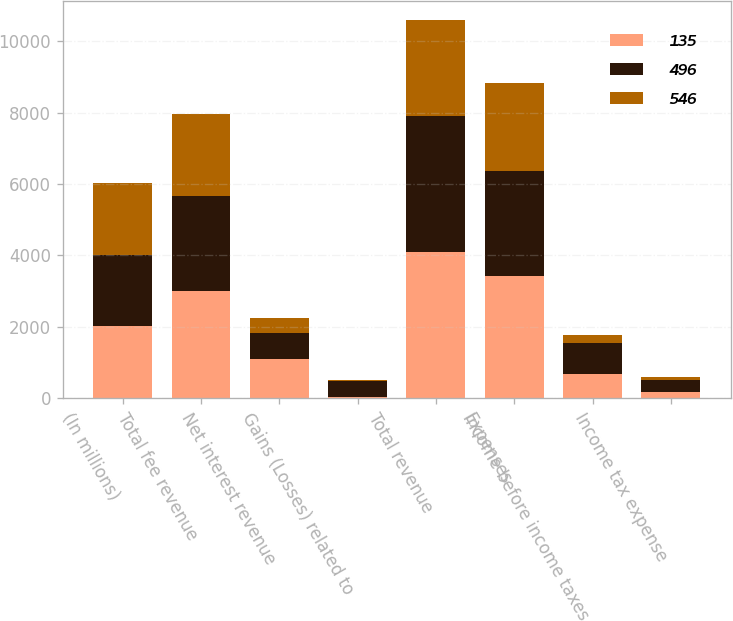Convert chart. <chart><loc_0><loc_0><loc_500><loc_500><stacked_bar_chart><ecel><fcel>(In millions)<fcel>Total fee revenue<fcel>Net interest revenue<fcel>Gains (Losses) related to<fcel>Total revenue<fcel>Expenses<fcel>Income before income taxes<fcel>Income tax expense<nl><fcel>135<fcel>2011<fcel>3004<fcel>1104<fcel>25<fcel>4083<fcel>3415<fcel>668<fcel>172<nl><fcel>496<fcel>2010<fcel>2661<fcel>725<fcel>449<fcel>3835<fcel>2962<fcel>873<fcel>327<nl><fcel>546<fcel>2009<fcel>2291<fcel>422<fcel>37<fcel>2676<fcel>2457<fcel>219<fcel>84<nl></chart> 